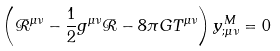<formula> <loc_0><loc_0><loc_500><loc_500>\left ( { \mathcal { R } } ^ { \mu \nu } - \frac { 1 } { 2 } g ^ { \mu \nu } { \mathcal { R } } - 8 \pi G T ^ { \mu \nu } \right ) y ^ { M } _ { ; \mu \nu } = 0</formula> 